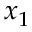Convert formula to latex. <formula><loc_0><loc_0><loc_500><loc_500>x _ { 1 }</formula> 